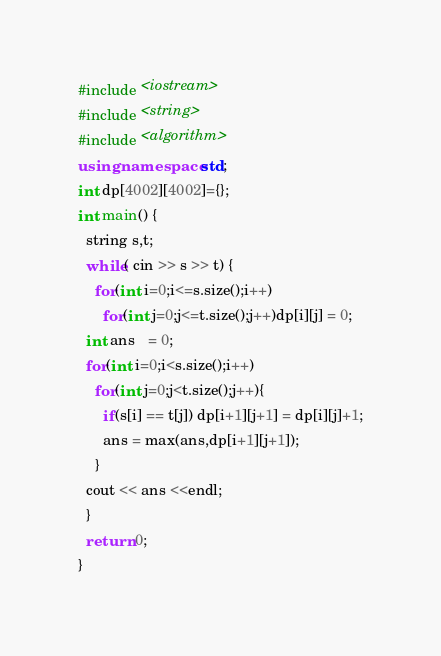Convert code to text. <code><loc_0><loc_0><loc_500><loc_500><_C++_>#include <iostream>
#include <string>
#include <algorithm>
using namespace std;
int dp[4002][4002]={};
int main() {
  string s,t;
  while( cin >> s >> t) {
    for(int i=0;i<=s.size();i++)
      for(int j=0;j<=t.size();j++)dp[i][j] = 0;
  int ans   = 0;
  for(int i=0;i<s.size();i++)
    for(int j=0;j<t.size();j++){
      if(s[i] == t[j]) dp[i+1][j+1] = dp[i][j]+1;
      ans = max(ans,dp[i+1][j+1]);
    }
  cout << ans <<endl;
  }
  return 0;
}</code> 